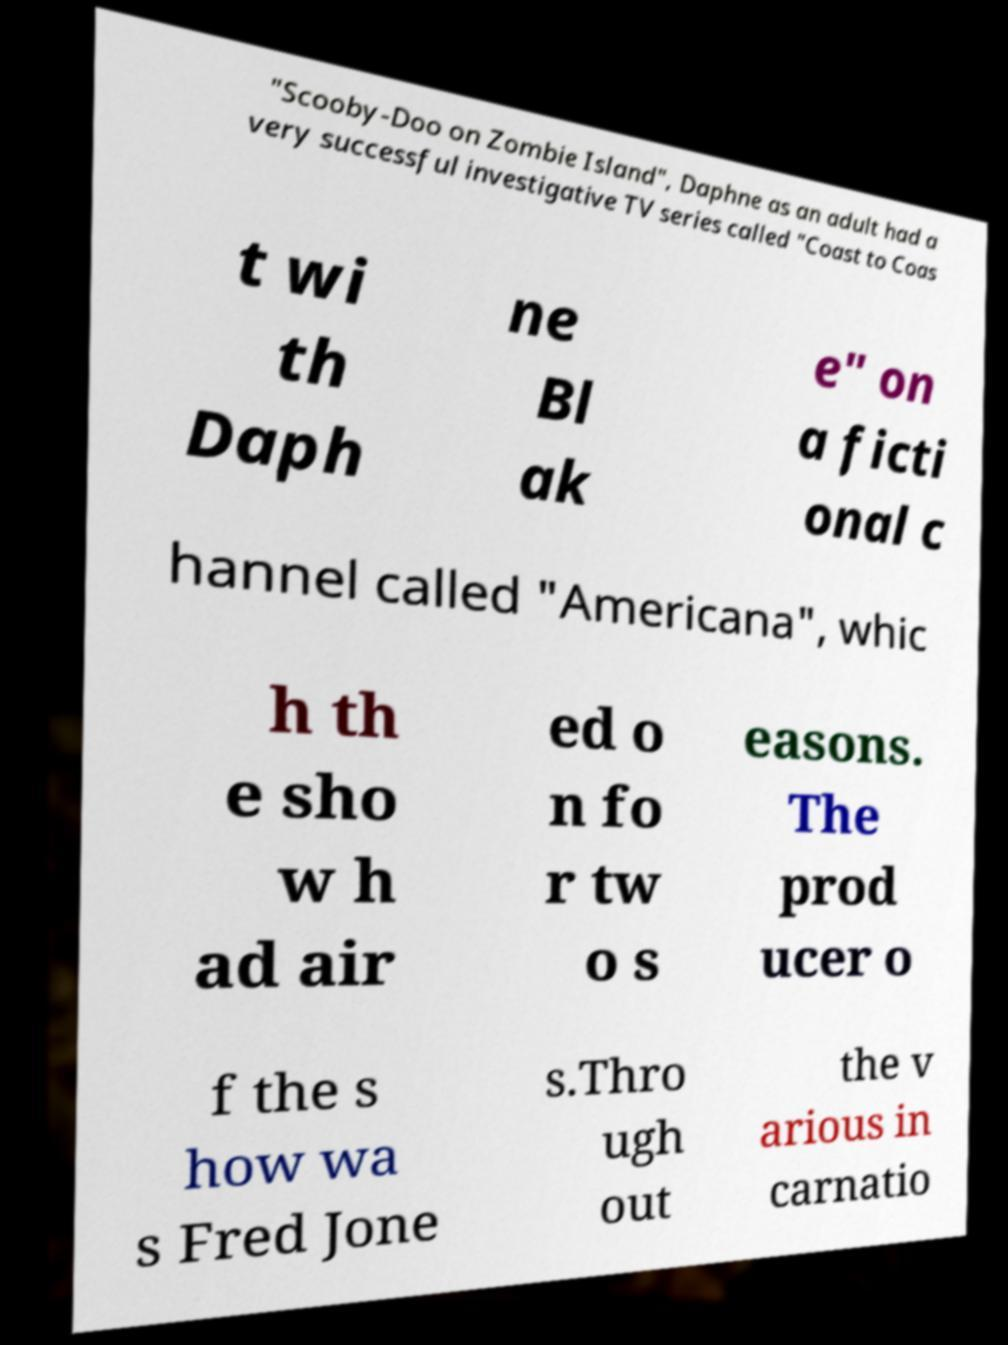Please read and relay the text visible in this image. What does it say? "Scooby-Doo on Zombie Island", Daphne as an adult had a very successful investigative TV series called "Coast to Coas t wi th Daph ne Bl ak e" on a ficti onal c hannel called "Americana", whic h th e sho w h ad air ed o n fo r tw o s easons. The prod ucer o f the s how wa s Fred Jone s.Thro ugh out the v arious in carnatio 